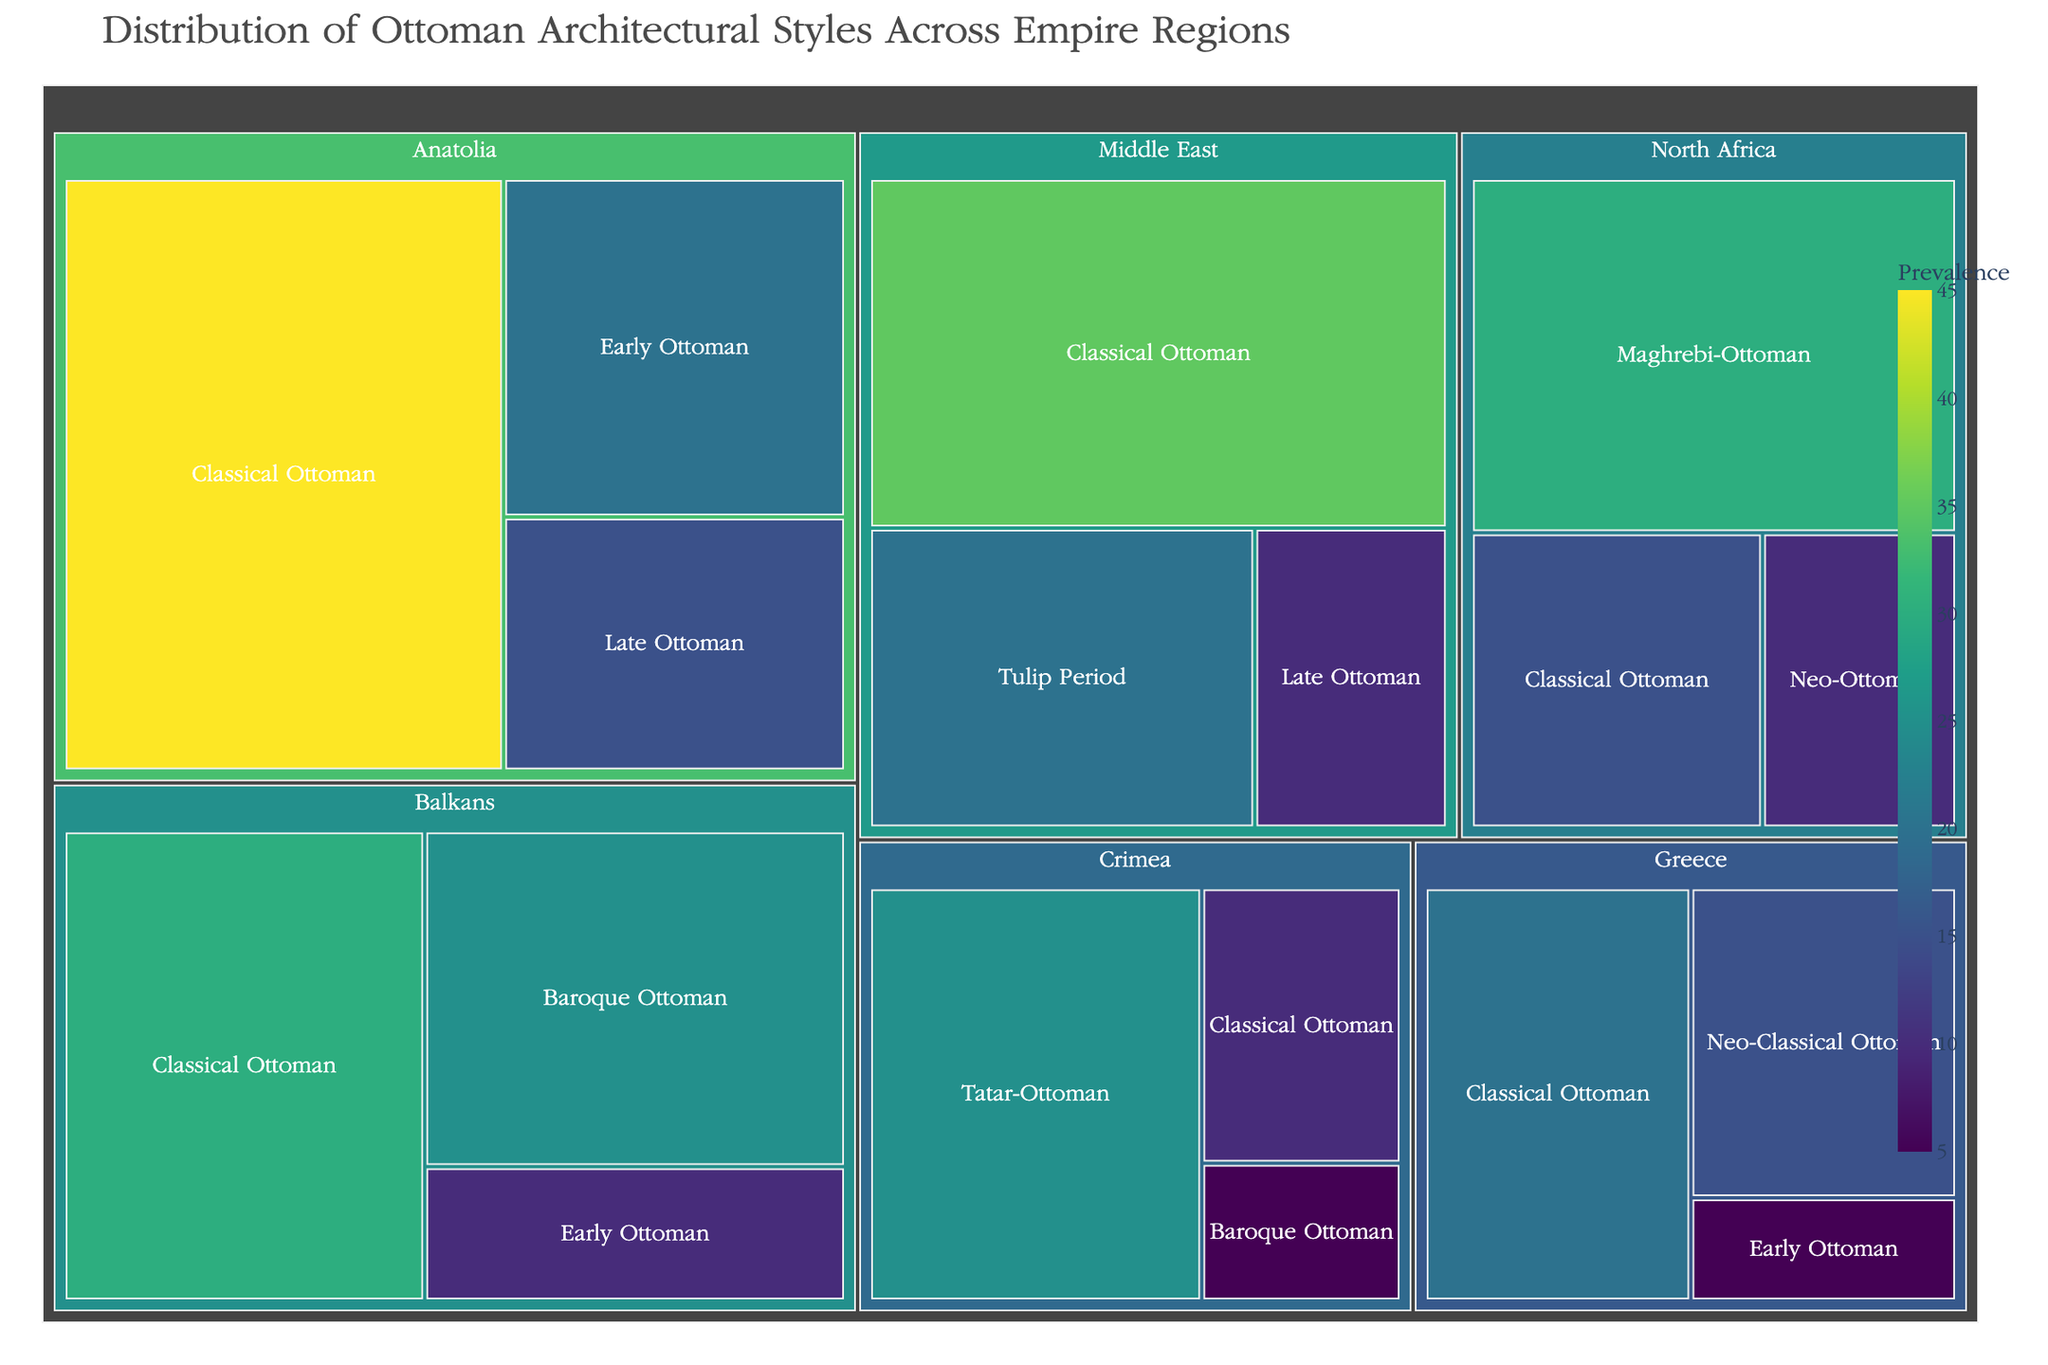What's the title of the treemap? The title of a treemap is usually displayed at the top of the chart. In this case, it is written in larger font and should be easy to spot.
Answer: Distribution of Ottoman Architectural Styles Across Empire Regions Which region has the highest prevalence of Classical Ottoman style? Locate the region tiles for Classical Ottoman style within the treemap and identify which one has the largest area or the highest value indicated for Classical Ottoman.
Answer: Anatolia What is the total prevalence of Ottoman architectural styles in the Middle East? To find the total prevalence in the Middle East, sum the values of all the styles in the Middle East region (Classical Ottoman, Tulip Period, Late Ottoman). 35 + 20 + 10 = 65
Answer: 65 Which region has the most diverse representation of Ottoman architectural styles? Count the number of different architectural styles listed for each region and find out which region has the highest count.
Answer: Anatolia How does the prevalence of Baroque Ottoman style in the Balkans compare to its prevalence in Crimea? Locate the values representing Baroque Ottoman style in the Balkans and Crimea, and compare these figures. The Balkans should have a larger area/value than Crimea.
Answer: Balkans is higher What is the overall prevalence of Early Ottoman style across all regions? Sum the prevalence of Early Ottoman style across all regions: Anatolia (20), Balkans (10), Greece (5). 20 + 10 + 5 = 35
Answer: 35 Which architectural style is unique to North Africa based on the treemap? Identify the style listed only under the North Africa region and not present in any other regions.
Answer: Maghrebi-Ottoman Which region has the lowest prevalence of Classical Ottoman style? Look for the region tile with the smallest area or value representing Classical Ottoman.
Answer: Crimea Calculate the difference in prevalence of Classical Ottoman style between Anatolia and the Middle East. Subtract the value of Classical Ottoman style in the Middle East (35) from that in Anatolia (45). 45 - 35 = 10
Answer: 10 What is the average prevalence of all architectural styles in Greece? Add up the prevalence values for each style in Greece (Classical Ottoman, Neo-Classical Ottoman, Early Ottoman), then divide by the number of styles. (20 + 15 + 5) / 3 = 40 / 3 ≈ 13.33
Answer: ≈ 13.33 